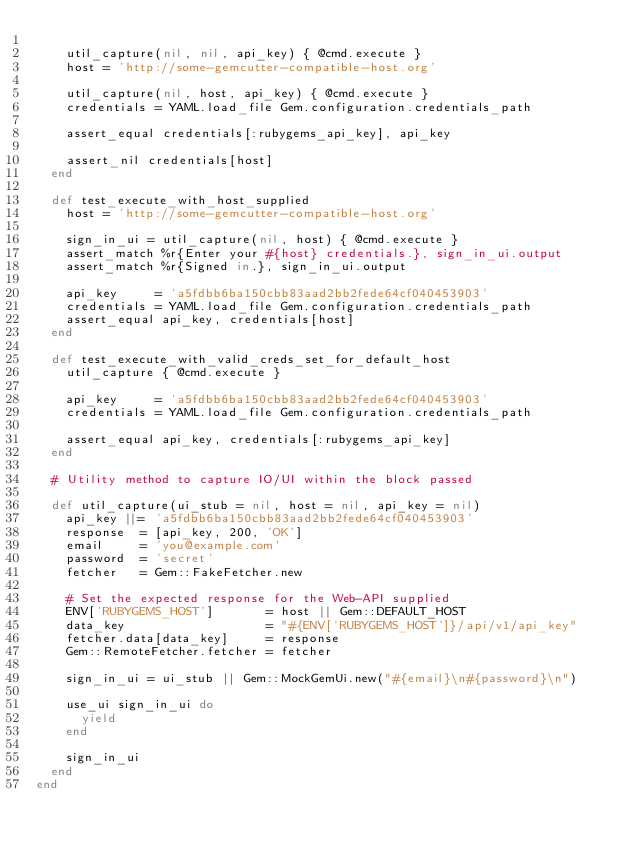<code> <loc_0><loc_0><loc_500><loc_500><_Ruby_>
    util_capture(nil, nil, api_key) { @cmd.execute }
    host = 'http://some-gemcutter-compatible-host.org'

    util_capture(nil, host, api_key) { @cmd.execute }
    credentials = YAML.load_file Gem.configuration.credentials_path

    assert_equal credentials[:rubygems_api_key], api_key

    assert_nil credentials[host]
  end

  def test_execute_with_host_supplied
    host = 'http://some-gemcutter-compatible-host.org'

    sign_in_ui = util_capture(nil, host) { @cmd.execute }
    assert_match %r{Enter your #{host} credentials.}, sign_in_ui.output
    assert_match %r{Signed in.}, sign_in_ui.output

    api_key     = 'a5fdbb6ba150cbb83aad2bb2fede64cf040453903'
    credentials = YAML.load_file Gem.configuration.credentials_path
    assert_equal api_key, credentials[host]
  end

  def test_execute_with_valid_creds_set_for_default_host
    util_capture { @cmd.execute }

    api_key     = 'a5fdbb6ba150cbb83aad2bb2fede64cf040453903'
    credentials = YAML.load_file Gem.configuration.credentials_path

    assert_equal api_key, credentials[:rubygems_api_key]
  end

  # Utility method to capture IO/UI within the block passed

  def util_capture(ui_stub = nil, host = nil, api_key = nil)
    api_key ||= 'a5fdbb6ba150cbb83aad2bb2fede64cf040453903'
    response  = [api_key, 200, 'OK']
    email     = 'you@example.com'
    password  = 'secret'
    fetcher   = Gem::FakeFetcher.new

    # Set the expected response for the Web-API supplied
    ENV['RUBYGEMS_HOST']       = host || Gem::DEFAULT_HOST
    data_key                   = "#{ENV['RUBYGEMS_HOST']}/api/v1/api_key"
    fetcher.data[data_key]     = response
    Gem::RemoteFetcher.fetcher = fetcher

    sign_in_ui = ui_stub || Gem::MockGemUi.new("#{email}\n#{password}\n")

    use_ui sign_in_ui do
      yield
    end

    sign_in_ui
  end
end
</code> 